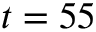Convert formula to latex. <formula><loc_0><loc_0><loc_500><loc_500>t = 5 5</formula> 